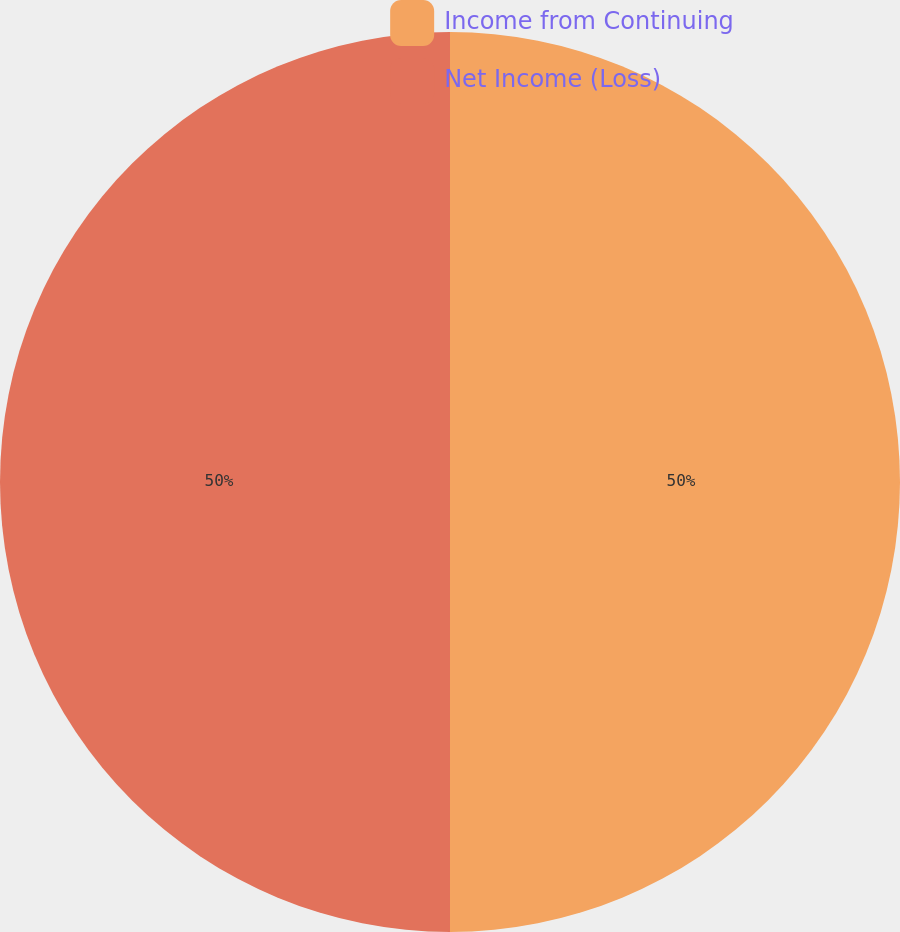<chart> <loc_0><loc_0><loc_500><loc_500><pie_chart><fcel>Income from Continuing<fcel>Net Income (Loss)<nl><fcel>50.0%<fcel>50.0%<nl></chart> 